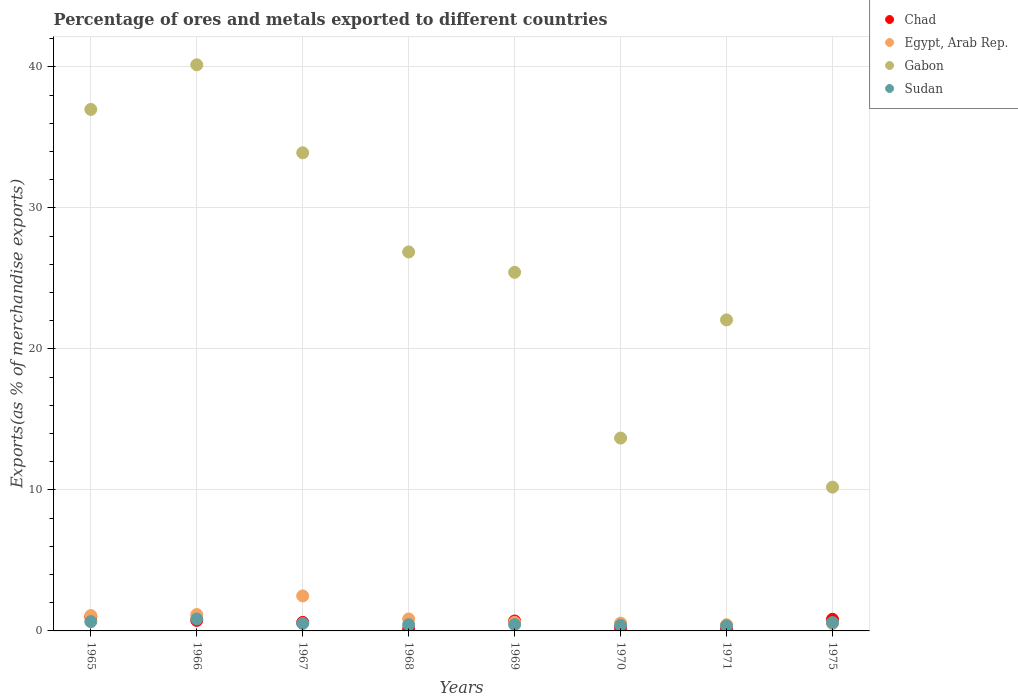Is the number of dotlines equal to the number of legend labels?
Your answer should be very brief. Yes. What is the percentage of exports to different countries in Egypt, Arab Rep. in 1967?
Provide a succinct answer. 2.48. Across all years, what is the maximum percentage of exports to different countries in Egypt, Arab Rep.?
Provide a succinct answer. 2.48. Across all years, what is the minimum percentage of exports to different countries in Sudan?
Offer a very short reply. 0.37. In which year was the percentage of exports to different countries in Chad maximum?
Ensure brevity in your answer.  1965. What is the total percentage of exports to different countries in Gabon in the graph?
Your response must be concise. 209.25. What is the difference between the percentage of exports to different countries in Chad in 1965 and that in 1966?
Offer a very short reply. 0.26. What is the difference between the percentage of exports to different countries in Egypt, Arab Rep. in 1967 and the percentage of exports to different countries in Chad in 1965?
Offer a very short reply. 1.48. What is the average percentage of exports to different countries in Sudan per year?
Offer a very short reply. 0.53. In the year 1967, what is the difference between the percentage of exports to different countries in Egypt, Arab Rep. and percentage of exports to different countries in Chad?
Your response must be concise. 1.88. What is the ratio of the percentage of exports to different countries in Sudan in 1966 to that in 1975?
Provide a succinct answer. 1.42. Is the difference between the percentage of exports to different countries in Egypt, Arab Rep. in 1965 and 1970 greater than the difference between the percentage of exports to different countries in Chad in 1965 and 1970?
Offer a very short reply. No. What is the difference between the highest and the second highest percentage of exports to different countries in Sudan?
Offer a very short reply. 0.19. What is the difference between the highest and the lowest percentage of exports to different countries in Chad?
Ensure brevity in your answer.  0.88. In how many years, is the percentage of exports to different countries in Egypt, Arab Rep. greater than the average percentage of exports to different countries in Egypt, Arab Rep. taken over all years?
Offer a terse response. 3. Is the sum of the percentage of exports to different countries in Gabon in 1969 and 1975 greater than the maximum percentage of exports to different countries in Egypt, Arab Rep. across all years?
Provide a short and direct response. Yes. Is it the case that in every year, the sum of the percentage of exports to different countries in Chad and percentage of exports to different countries in Gabon  is greater than the sum of percentage of exports to different countries in Egypt, Arab Rep. and percentage of exports to different countries in Sudan?
Offer a terse response. Yes. Is it the case that in every year, the sum of the percentage of exports to different countries in Chad and percentage of exports to different countries in Egypt, Arab Rep.  is greater than the percentage of exports to different countries in Sudan?
Your answer should be very brief. Yes. Does the percentage of exports to different countries in Gabon monotonically increase over the years?
Offer a very short reply. No. Is the percentage of exports to different countries in Egypt, Arab Rep. strictly greater than the percentage of exports to different countries in Sudan over the years?
Provide a succinct answer. No. How many years are there in the graph?
Provide a short and direct response. 8. What is the difference between two consecutive major ticks on the Y-axis?
Your answer should be very brief. 10. Are the values on the major ticks of Y-axis written in scientific E-notation?
Provide a short and direct response. No. Does the graph contain any zero values?
Your answer should be compact. No. Does the graph contain grids?
Keep it short and to the point. Yes. Where does the legend appear in the graph?
Your response must be concise. Top right. How many legend labels are there?
Your answer should be compact. 4. What is the title of the graph?
Keep it short and to the point. Percentage of ores and metals exported to different countries. Does "Belize" appear as one of the legend labels in the graph?
Keep it short and to the point. No. What is the label or title of the Y-axis?
Your answer should be compact. Exports(as % of merchandise exports). What is the Exports(as % of merchandise exports) in Chad in 1965?
Your answer should be very brief. 1.01. What is the Exports(as % of merchandise exports) in Egypt, Arab Rep. in 1965?
Keep it short and to the point. 1.09. What is the Exports(as % of merchandise exports) of Gabon in 1965?
Offer a very short reply. 36.98. What is the Exports(as % of merchandise exports) in Sudan in 1965?
Your answer should be compact. 0.66. What is the Exports(as % of merchandise exports) in Chad in 1966?
Ensure brevity in your answer.  0.75. What is the Exports(as % of merchandise exports) of Egypt, Arab Rep. in 1966?
Make the answer very short. 1.16. What is the Exports(as % of merchandise exports) of Gabon in 1966?
Provide a short and direct response. 40.14. What is the Exports(as % of merchandise exports) in Sudan in 1966?
Make the answer very short. 0.85. What is the Exports(as % of merchandise exports) of Chad in 1967?
Ensure brevity in your answer.  0.61. What is the Exports(as % of merchandise exports) of Egypt, Arab Rep. in 1967?
Your answer should be very brief. 2.48. What is the Exports(as % of merchandise exports) of Gabon in 1967?
Your answer should be compact. 33.9. What is the Exports(as % of merchandise exports) of Sudan in 1967?
Your response must be concise. 0.53. What is the Exports(as % of merchandise exports) in Chad in 1968?
Ensure brevity in your answer.  0.12. What is the Exports(as % of merchandise exports) in Egypt, Arab Rep. in 1968?
Make the answer very short. 0.85. What is the Exports(as % of merchandise exports) in Gabon in 1968?
Offer a terse response. 26.87. What is the Exports(as % of merchandise exports) of Sudan in 1968?
Make the answer very short. 0.44. What is the Exports(as % of merchandise exports) of Chad in 1969?
Provide a short and direct response. 0.7. What is the Exports(as % of merchandise exports) in Egypt, Arab Rep. in 1969?
Offer a terse response. 0.61. What is the Exports(as % of merchandise exports) of Gabon in 1969?
Provide a succinct answer. 25.43. What is the Exports(as % of merchandise exports) in Sudan in 1969?
Make the answer very short. 0.45. What is the Exports(as % of merchandise exports) of Chad in 1970?
Make the answer very short. 0.22. What is the Exports(as % of merchandise exports) of Egypt, Arab Rep. in 1970?
Provide a succinct answer. 0.55. What is the Exports(as % of merchandise exports) in Gabon in 1970?
Your answer should be compact. 13.68. What is the Exports(as % of merchandise exports) of Sudan in 1970?
Your answer should be very brief. 0.39. What is the Exports(as % of merchandise exports) of Chad in 1971?
Your answer should be very brief. 0.16. What is the Exports(as % of merchandise exports) in Egypt, Arab Rep. in 1971?
Your answer should be very brief. 0.44. What is the Exports(as % of merchandise exports) in Gabon in 1971?
Offer a very short reply. 22.05. What is the Exports(as % of merchandise exports) in Sudan in 1971?
Make the answer very short. 0.37. What is the Exports(as % of merchandise exports) of Chad in 1975?
Offer a terse response. 0.82. What is the Exports(as % of merchandise exports) in Egypt, Arab Rep. in 1975?
Provide a succinct answer. 0.52. What is the Exports(as % of merchandise exports) in Gabon in 1975?
Provide a short and direct response. 10.19. What is the Exports(as % of merchandise exports) in Sudan in 1975?
Your response must be concise. 0.59. Across all years, what is the maximum Exports(as % of merchandise exports) in Chad?
Make the answer very short. 1.01. Across all years, what is the maximum Exports(as % of merchandise exports) of Egypt, Arab Rep.?
Your response must be concise. 2.48. Across all years, what is the maximum Exports(as % of merchandise exports) in Gabon?
Your answer should be very brief. 40.14. Across all years, what is the maximum Exports(as % of merchandise exports) of Sudan?
Your answer should be very brief. 0.85. Across all years, what is the minimum Exports(as % of merchandise exports) in Chad?
Your answer should be very brief. 0.12. Across all years, what is the minimum Exports(as % of merchandise exports) in Egypt, Arab Rep.?
Make the answer very short. 0.44. Across all years, what is the minimum Exports(as % of merchandise exports) in Gabon?
Ensure brevity in your answer.  10.19. Across all years, what is the minimum Exports(as % of merchandise exports) in Sudan?
Provide a succinct answer. 0.37. What is the total Exports(as % of merchandise exports) of Chad in the graph?
Offer a very short reply. 4.38. What is the total Exports(as % of merchandise exports) of Egypt, Arab Rep. in the graph?
Provide a succinct answer. 7.7. What is the total Exports(as % of merchandise exports) in Gabon in the graph?
Keep it short and to the point. 209.25. What is the total Exports(as % of merchandise exports) in Sudan in the graph?
Give a very brief answer. 4.27. What is the difference between the Exports(as % of merchandise exports) in Chad in 1965 and that in 1966?
Keep it short and to the point. 0.26. What is the difference between the Exports(as % of merchandise exports) of Egypt, Arab Rep. in 1965 and that in 1966?
Make the answer very short. -0.07. What is the difference between the Exports(as % of merchandise exports) of Gabon in 1965 and that in 1966?
Provide a short and direct response. -3.17. What is the difference between the Exports(as % of merchandise exports) of Sudan in 1965 and that in 1966?
Offer a terse response. -0.19. What is the difference between the Exports(as % of merchandise exports) in Chad in 1965 and that in 1967?
Provide a succinct answer. 0.4. What is the difference between the Exports(as % of merchandise exports) of Egypt, Arab Rep. in 1965 and that in 1967?
Offer a very short reply. -1.39. What is the difference between the Exports(as % of merchandise exports) in Gabon in 1965 and that in 1967?
Your answer should be very brief. 3.07. What is the difference between the Exports(as % of merchandise exports) of Sudan in 1965 and that in 1967?
Ensure brevity in your answer.  0.13. What is the difference between the Exports(as % of merchandise exports) in Chad in 1965 and that in 1968?
Offer a very short reply. 0.88. What is the difference between the Exports(as % of merchandise exports) in Egypt, Arab Rep. in 1965 and that in 1968?
Your answer should be compact. 0.24. What is the difference between the Exports(as % of merchandise exports) in Gabon in 1965 and that in 1968?
Your answer should be very brief. 10.1. What is the difference between the Exports(as % of merchandise exports) in Sudan in 1965 and that in 1968?
Keep it short and to the point. 0.22. What is the difference between the Exports(as % of merchandise exports) in Chad in 1965 and that in 1969?
Keep it short and to the point. 0.3. What is the difference between the Exports(as % of merchandise exports) in Egypt, Arab Rep. in 1965 and that in 1969?
Offer a terse response. 0.48. What is the difference between the Exports(as % of merchandise exports) of Gabon in 1965 and that in 1969?
Your answer should be very brief. 11.55. What is the difference between the Exports(as % of merchandise exports) of Sudan in 1965 and that in 1969?
Provide a short and direct response. 0.21. What is the difference between the Exports(as % of merchandise exports) in Chad in 1965 and that in 1970?
Ensure brevity in your answer.  0.79. What is the difference between the Exports(as % of merchandise exports) of Egypt, Arab Rep. in 1965 and that in 1970?
Provide a succinct answer. 0.53. What is the difference between the Exports(as % of merchandise exports) in Gabon in 1965 and that in 1970?
Offer a terse response. 23.3. What is the difference between the Exports(as % of merchandise exports) in Sudan in 1965 and that in 1970?
Give a very brief answer. 0.27. What is the difference between the Exports(as % of merchandise exports) in Chad in 1965 and that in 1971?
Your response must be concise. 0.85. What is the difference between the Exports(as % of merchandise exports) of Egypt, Arab Rep. in 1965 and that in 1971?
Make the answer very short. 0.65. What is the difference between the Exports(as % of merchandise exports) in Gabon in 1965 and that in 1971?
Your response must be concise. 14.92. What is the difference between the Exports(as % of merchandise exports) of Sudan in 1965 and that in 1971?
Keep it short and to the point. 0.29. What is the difference between the Exports(as % of merchandise exports) of Chad in 1965 and that in 1975?
Offer a terse response. 0.18. What is the difference between the Exports(as % of merchandise exports) in Egypt, Arab Rep. in 1965 and that in 1975?
Your answer should be compact. 0.56. What is the difference between the Exports(as % of merchandise exports) of Gabon in 1965 and that in 1975?
Your response must be concise. 26.78. What is the difference between the Exports(as % of merchandise exports) of Sudan in 1965 and that in 1975?
Provide a succinct answer. 0.07. What is the difference between the Exports(as % of merchandise exports) of Chad in 1966 and that in 1967?
Provide a short and direct response. 0.14. What is the difference between the Exports(as % of merchandise exports) of Egypt, Arab Rep. in 1966 and that in 1967?
Keep it short and to the point. -1.32. What is the difference between the Exports(as % of merchandise exports) of Gabon in 1966 and that in 1967?
Offer a terse response. 6.24. What is the difference between the Exports(as % of merchandise exports) of Sudan in 1966 and that in 1967?
Provide a short and direct response. 0.32. What is the difference between the Exports(as % of merchandise exports) in Chad in 1966 and that in 1968?
Offer a very short reply. 0.62. What is the difference between the Exports(as % of merchandise exports) in Egypt, Arab Rep. in 1966 and that in 1968?
Provide a short and direct response. 0.31. What is the difference between the Exports(as % of merchandise exports) of Gabon in 1966 and that in 1968?
Keep it short and to the point. 13.27. What is the difference between the Exports(as % of merchandise exports) of Sudan in 1966 and that in 1968?
Your answer should be compact. 0.41. What is the difference between the Exports(as % of merchandise exports) of Chad in 1966 and that in 1969?
Offer a very short reply. 0.04. What is the difference between the Exports(as % of merchandise exports) of Egypt, Arab Rep. in 1966 and that in 1969?
Your answer should be compact. 0.55. What is the difference between the Exports(as % of merchandise exports) of Gabon in 1966 and that in 1969?
Ensure brevity in your answer.  14.71. What is the difference between the Exports(as % of merchandise exports) of Chad in 1966 and that in 1970?
Offer a terse response. 0.53. What is the difference between the Exports(as % of merchandise exports) of Egypt, Arab Rep. in 1966 and that in 1970?
Provide a short and direct response. 0.61. What is the difference between the Exports(as % of merchandise exports) in Gabon in 1966 and that in 1970?
Ensure brevity in your answer.  26.47. What is the difference between the Exports(as % of merchandise exports) in Sudan in 1966 and that in 1970?
Offer a very short reply. 0.45. What is the difference between the Exports(as % of merchandise exports) of Chad in 1966 and that in 1971?
Keep it short and to the point. 0.59. What is the difference between the Exports(as % of merchandise exports) of Egypt, Arab Rep. in 1966 and that in 1971?
Your answer should be very brief. 0.72. What is the difference between the Exports(as % of merchandise exports) of Gabon in 1966 and that in 1971?
Provide a short and direct response. 18.09. What is the difference between the Exports(as % of merchandise exports) in Sudan in 1966 and that in 1971?
Offer a very short reply. 0.48. What is the difference between the Exports(as % of merchandise exports) of Chad in 1966 and that in 1975?
Your response must be concise. -0.08. What is the difference between the Exports(as % of merchandise exports) of Egypt, Arab Rep. in 1966 and that in 1975?
Offer a very short reply. 0.64. What is the difference between the Exports(as % of merchandise exports) of Gabon in 1966 and that in 1975?
Provide a short and direct response. 29.95. What is the difference between the Exports(as % of merchandise exports) of Sudan in 1966 and that in 1975?
Offer a terse response. 0.25. What is the difference between the Exports(as % of merchandise exports) of Chad in 1967 and that in 1968?
Keep it short and to the point. 0.48. What is the difference between the Exports(as % of merchandise exports) in Egypt, Arab Rep. in 1967 and that in 1968?
Your answer should be very brief. 1.63. What is the difference between the Exports(as % of merchandise exports) of Gabon in 1967 and that in 1968?
Your response must be concise. 7.03. What is the difference between the Exports(as % of merchandise exports) of Sudan in 1967 and that in 1968?
Keep it short and to the point. 0.09. What is the difference between the Exports(as % of merchandise exports) in Chad in 1967 and that in 1969?
Keep it short and to the point. -0.1. What is the difference between the Exports(as % of merchandise exports) of Egypt, Arab Rep. in 1967 and that in 1969?
Your answer should be compact. 1.88. What is the difference between the Exports(as % of merchandise exports) in Gabon in 1967 and that in 1969?
Give a very brief answer. 8.48. What is the difference between the Exports(as % of merchandise exports) of Sudan in 1967 and that in 1969?
Your answer should be compact. 0.08. What is the difference between the Exports(as % of merchandise exports) in Chad in 1967 and that in 1970?
Provide a short and direct response. 0.39. What is the difference between the Exports(as % of merchandise exports) of Egypt, Arab Rep. in 1967 and that in 1970?
Ensure brevity in your answer.  1.93. What is the difference between the Exports(as % of merchandise exports) of Gabon in 1967 and that in 1970?
Your answer should be very brief. 20.23. What is the difference between the Exports(as % of merchandise exports) in Sudan in 1967 and that in 1970?
Give a very brief answer. 0.14. What is the difference between the Exports(as % of merchandise exports) in Chad in 1967 and that in 1971?
Give a very brief answer. 0.45. What is the difference between the Exports(as % of merchandise exports) of Egypt, Arab Rep. in 1967 and that in 1971?
Ensure brevity in your answer.  2.04. What is the difference between the Exports(as % of merchandise exports) of Gabon in 1967 and that in 1971?
Your answer should be very brief. 11.85. What is the difference between the Exports(as % of merchandise exports) in Sudan in 1967 and that in 1971?
Provide a short and direct response. 0.17. What is the difference between the Exports(as % of merchandise exports) in Chad in 1967 and that in 1975?
Offer a terse response. -0.22. What is the difference between the Exports(as % of merchandise exports) of Egypt, Arab Rep. in 1967 and that in 1975?
Your response must be concise. 1.96. What is the difference between the Exports(as % of merchandise exports) of Gabon in 1967 and that in 1975?
Your answer should be compact. 23.71. What is the difference between the Exports(as % of merchandise exports) in Sudan in 1967 and that in 1975?
Your response must be concise. -0.06. What is the difference between the Exports(as % of merchandise exports) of Chad in 1968 and that in 1969?
Provide a succinct answer. -0.58. What is the difference between the Exports(as % of merchandise exports) in Egypt, Arab Rep. in 1968 and that in 1969?
Provide a short and direct response. 0.24. What is the difference between the Exports(as % of merchandise exports) of Gabon in 1968 and that in 1969?
Your answer should be very brief. 1.44. What is the difference between the Exports(as % of merchandise exports) in Sudan in 1968 and that in 1969?
Make the answer very short. -0.01. What is the difference between the Exports(as % of merchandise exports) in Chad in 1968 and that in 1970?
Provide a succinct answer. -0.1. What is the difference between the Exports(as % of merchandise exports) of Egypt, Arab Rep. in 1968 and that in 1970?
Keep it short and to the point. 0.29. What is the difference between the Exports(as % of merchandise exports) of Gabon in 1968 and that in 1970?
Provide a short and direct response. 13.2. What is the difference between the Exports(as % of merchandise exports) in Sudan in 1968 and that in 1970?
Your answer should be very brief. 0.05. What is the difference between the Exports(as % of merchandise exports) in Chad in 1968 and that in 1971?
Give a very brief answer. -0.04. What is the difference between the Exports(as % of merchandise exports) in Egypt, Arab Rep. in 1968 and that in 1971?
Provide a short and direct response. 0.41. What is the difference between the Exports(as % of merchandise exports) of Gabon in 1968 and that in 1971?
Provide a short and direct response. 4.82. What is the difference between the Exports(as % of merchandise exports) in Sudan in 1968 and that in 1971?
Provide a succinct answer. 0.07. What is the difference between the Exports(as % of merchandise exports) of Chad in 1968 and that in 1975?
Provide a succinct answer. -0.7. What is the difference between the Exports(as % of merchandise exports) of Egypt, Arab Rep. in 1968 and that in 1975?
Offer a terse response. 0.32. What is the difference between the Exports(as % of merchandise exports) of Gabon in 1968 and that in 1975?
Give a very brief answer. 16.68. What is the difference between the Exports(as % of merchandise exports) in Sudan in 1968 and that in 1975?
Provide a short and direct response. -0.15. What is the difference between the Exports(as % of merchandise exports) in Chad in 1969 and that in 1970?
Your answer should be compact. 0.48. What is the difference between the Exports(as % of merchandise exports) in Egypt, Arab Rep. in 1969 and that in 1970?
Your answer should be compact. 0.05. What is the difference between the Exports(as % of merchandise exports) of Gabon in 1969 and that in 1970?
Make the answer very short. 11.75. What is the difference between the Exports(as % of merchandise exports) in Sudan in 1969 and that in 1970?
Your answer should be compact. 0.05. What is the difference between the Exports(as % of merchandise exports) in Chad in 1969 and that in 1971?
Your answer should be very brief. 0.54. What is the difference between the Exports(as % of merchandise exports) in Egypt, Arab Rep. in 1969 and that in 1971?
Make the answer very short. 0.17. What is the difference between the Exports(as % of merchandise exports) of Gabon in 1969 and that in 1971?
Provide a succinct answer. 3.37. What is the difference between the Exports(as % of merchandise exports) of Sudan in 1969 and that in 1971?
Provide a short and direct response. 0.08. What is the difference between the Exports(as % of merchandise exports) in Chad in 1969 and that in 1975?
Make the answer very short. -0.12. What is the difference between the Exports(as % of merchandise exports) of Egypt, Arab Rep. in 1969 and that in 1975?
Offer a terse response. 0.08. What is the difference between the Exports(as % of merchandise exports) of Gabon in 1969 and that in 1975?
Offer a terse response. 15.23. What is the difference between the Exports(as % of merchandise exports) in Sudan in 1969 and that in 1975?
Give a very brief answer. -0.15. What is the difference between the Exports(as % of merchandise exports) of Chad in 1970 and that in 1971?
Provide a succinct answer. 0.06. What is the difference between the Exports(as % of merchandise exports) in Egypt, Arab Rep. in 1970 and that in 1971?
Keep it short and to the point. 0.12. What is the difference between the Exports(as % of merchandise exports) in Gabon in 1970 and that in 1971?
Your answer should be very brief. -8.38. What is the difference between the Exports(as % of merchandise exports) of Sudan in 1970 and that in 1971?
Your answer should be very brief. 0.03. What is the difference between the Exports(as % of merchandise exports) of Chad in 1970 and that in 1975?
Provide a short and direct response. -0.6. What is the difference between the Exports(as % of merchandise exports) of Egypt, Arab Rep. in 1970 and that in 1975?
Your answer should be compact. 0.03. What is the difference between the Exports(as % of merchandise exports) of Gabon in 1970 and that in 1975?
Give a very brief answer. 3.48. What is the difference between the Exports(as % of merchandise exports) of Sudan in 1970 and that in 1975?
Offer a terse response. -0.2. What is the difference between the Exports(as % of merchandise exports) of Chad in 1971 and that in 1975?
Offer a terse response. -0.66. What is the difference between the Exports(as % of merchandise exports) of Egypt, Arab Rep. in 1971 and that in 1975?
Your answer should be compact. -0.09. What is the difference between the Exports(as % of merchandise exports) in Gabon in 1971 and that in 1975?
Make the answer very short. 11.86. What is the difference between the Exports(as % of merchandise exports) in Sudan in 1971 and that in 1975?
Your response must be concise. -0.23. What is the difference between the Exports(as % of merchandise exports) in Chad in 1965 and the Exports(as % of merchandise exports) in Egypt, Arab Rep. in 1966?
Your answer should be compact. -0.15. What is the difference between the Exports(as % of merchandise exports) of Chad in 1965 and the Exports(as % of merchandise exports) of Gabon in 1966?
Provide a short and direct response. -39.14. What is the difference between the Exports(as % of merchandise exports) of Chad in 1965 and the Exports(as % of merchandise exports) of Sudan in 1966?
Keep it short and to the point. 0.16. What is the difference between the Exports(as % of merchandise exports) in Egypt, Arab Rep. in 1965 and the Exports(as % of merchandise exports) in Gabon in 1966?
Keep it short and to the point. -39.05. What is the difference between the Exports(as % of merchandise exports) in Egypt, Arab Rep. in 1965 and the Exports(as % of merchandise exports) in Sudan in 1966?
Offer a terse response. 0.24. What is the difference between the Exports(as % of merchandise exports) of Gabon in 1965 and the Exports(as % of merchandise exports) of Sudan in 1966?
Provide a succinct answer. 36.13. What is the difference between the Exports(as % of merchandise exports) of Chad in 1965 and the Exports(as % of merchandise exports) of Egypt, Arab Rep. in 1967?
Provide a short and direct response. -1.48. What is the difference between the Exports(as % of merchandise exports) in Chad in 1965 and the Exports(as % of merchandise exports) in Gabon in 1967?
Keep it short and to the point. -32.9. What is the difference between the Exports(as % of merchandise exports) of Chad in 1965 and the Exports(as % of merchandise exports) of Sudan in 1967?
Provide a succinct answer. 0.48. What is the difference between the Exports(as % of merchandise exports) in Egypt, Arab Rep. in 1965 and the Exports(as % of merchandise exports) in Gabon in 1967?
Your answer should be compact. -32.82. What is the difference between the Exports(as % of merchandise exports) in Egypt, Arab Rep. in 1965 and the Exports(as % of merchandise exports) in Sudan in 1967?
Offer a terse response. 0.56. What is the difference between the Exports(as % of merchandise exports) of Gabon in 1965 and the Exports(as % of merchandise exports) of Sudan in 1967?
Provide a succinct answer. 36.45. What is the difference between the Exports(as % of merchandise exports) of Chad in 1965 and the Exports(as % of merchandise exports) of Egypt, Arab Rep. in 1968?
Your response must be concise. 0.16. What is the difference between the Exports(as % of merchandise exports) of Chad in 1965 and the Exports(as % of merchandise exports) of Gabon in 1968?
Ensure brevity in your answer.  -25.87. What is the difference between the Exports(as % of merchandise exports) of Chad in 1965 and the Exports(as % of merchandise exports) of Sudan in 1968?
Your response must be concise. 0.57. What is the difference between the Exports(as % of merchandise exports) of Egypt, Arab Rep. in 1965 and the Exports(as % of merchandise exports) of Gabon in 1968?
Give a very brief answer. -25.78. What is the difference between the Exports(as % of merchandise exports) of Egypt, Arab Rep. in 1965 and the Exports(as % of merchandise exports) of Sudan in 1968?
Give a very brief answer. 0.65. What is the difference between the Exports(as % of merchandise exports) in Gabon in 1965 and the Exports(as % of merchandise exports) in Sudan in 1968?
Offer a terse response. 36.54. What is the difference between the Exports(as % of merchandise exports) of Chad in 1965 and the Exports(as % of merchandise exports) of Egypt, Arab Rep. in 1969?
Your response must be concise. 0.4. What is the difference between the Exports(as % of merchandise exports) in Chad in 1965 and the Exports(as % of merchandise exports) in Gabon in 1969?
Ensure brevity in your answer.  -24.42. What is the difference between the Exports(as % of merchandise exports) of Chad in 1965 and the Exports(as % of merchandise exports) of Sudan in 1969?
Your response must be concise. 0.56. What is the difference between the Exports(as % of merchandise exports) in Egypt, Arab Rep. in 1965 and the Exports(as % of merchandise exports) in Gabon in 1969?
Give a very brief answer. -24.34. What is the difference between the Exports(as % of merchandise exports) in Egypt, Arab Rep. in 1965 and the Exports(as % of merchandise exports) in Sudan in 1969?
Your answer should be compact. 0.64. What is the difference between the Exports(as % of merchandise exports) of Gabon in 1965 and the Exports(as % of merchandise exports) of Sudan in 1969?
Make the answer very short. 36.53. What is the difference between the Exports(as % of merchandise exports) in Chad in 1965 and the Exports(as % of merchandise exports) in Egypt, Arab Rep. in 1970?
Your answer should be compact. 0.45. What is the difference between the Exports(as % of merchandise exports) in Chad in 1965 and the Exports(as % of merchandise exports) in Gabon in 1970?
Make the answer very short. -12.67. What is the difference between the Exports(as % of merchandise exports) of Chad in 1965 and the Exports(as % of merchandise exports) of Sudan in 1970?
Ensure brevity in your answer.  0.61. What is the difference between the Exports(as % of merchandise exports) in Egypt, Arab Rep. in 1965 and the Exports(as % of merchandise exports) in Gabon in 1970?
Offer a terse response. -12.59. What is the difference between the Exports(as % of merchandise exports) in Egypt, Arab Rep. in 1965 and the Exports(as % of merchandise exports) in Sudan in 1970?
Ensure brevity in your answer.  0.7. What is the difference between the Exports(as % of merchandise exports) of Gabon in 1965 and the Exports(as % of merchandise exports) of Sudan in 1970?
Keep it short and to the point. 36.58. What is the difference between the Exports(as % of merchandise exports) in Chad in 1965 and the Exports(as % of merchandise exports) in Egypt, Arab Rep. in 1971?
Offer a very short reply. 0.57. What is the difference between the Exports(as % of merchandise exports) of Chad in 1965 and the Exports(as % of merchandise exports) of Gabon in 1971?
Ensure brevity in your answer.  -21.05. What is the difference between the Exports(as % of merchandise exports) of Chad in 1965 and the Exports(as % of merchandise exports) of Sudan in 1971?
Provide a succinct answer. 0.64. What is the difference between the Exports(as % of merchandise exports) in Egypt, Arab Rep. in 1965 and the Exports(as % of merchandise exports) in Gabon in 1971?
Your answer should be compact. -20.97. What is the difference between the Exports(as % of merchandise exports) in Egypt, Arab Rep. in 1965 and the Exports(as % of merchandise exports) in Sudan in 1971?
Keep it short and to the point. 0.72. What is the difference between the Exports(as % of merchandise exports) in Gabon in 1965 and the Exports(as % of merchandise exports) in Sudan in 1971?
Ensure brevity in your answer.  36.61. What is the difference between the Exports(as % of merchandise exports) in Chad in 1965 and the Exports(as % of merchandise exports) in Egypt, Arab Rep. in 1975?
Keep it short and to the point. 0.48. What is the difference between the Exports(as % of merchandise exports) of Chad in 1965 and the Exports(as % of merchandise exports) of Gabon in 1975?
Make the answer very short. -9.19. What is the difference between the Exports(as % of merchandise exports) of Chad in 1965 and the Exports(as % of merchandise exports) of Sudan in 1975?
Your response must be concise. 0.41. What is the difference between the Exports(as % of merchandise exports) in Egypt, Arab Rep. in 1965 and the Exports(as % of merchandise exports) in Gabon in 1975?
Your response must be concise. -9.11. What is the difference between the Exports(as % of merchandise exports) of Egypt, Arab Rep. in 1965 and the Exports(as % of merchandise exports) of Sudan in 1975?
Provide a short and direct response. 0.49. What is the difference between the Exports(as % of merchandise exports) of Gabon in 1965 and the Exports(as % of merchandise exports) of Sudan in 1975?
Your response must be concise. 36.38. What is the difference between the Exports(as % of merchandise exports) of Chad in 1966 and the Exports(as % of merchandise exports) of Egypt, Arab Rep. in 1967?
Ensure brevity in your answer.  -1.74. What is the difference between the Exports(as % of merchandise exports) of Chad in 1966 and the Exports(as % of merchandise exports) of Gabon in 1967?
Give a very brief answer. -33.16. What is the difference between the Exports(as % of merchandise exports) of Chad in 1966 and the Exports(as % of merchandise exports) of Sudan in 1967?
Offer a terse response. 0.22. What is the difference between the Exports(as % of merchandise exports) of Egypt, Arab Rep. in 1966 and the Exports(as % of merchandise exports) of Gabon in 1967?
Your answer should be compact. -32.74. What is the difference between the Exports(as % of merchandise exports) of Egypt, Arab Rep. in 1966 and the Exports(as % of merchandise exports) of Sudan in 1967?
Ensure brevity in your answer.  0.63. What is the difference between the Exports(as % of merchandise exports) in Gabon in 1966 and the Exports(as % of merchandise exports) in Sudan in 1967?
Offer a terse response. 39.61. What is the difference between the Exports(as % of merchandise exports) in Chad in 1966 and the Exports(as % of merchandise exports) in Egypt, Arab Rep. in 1968?
Your answer should be compact. -0.1. What is the difference between the Exports(as % of merchandise exports) in Chad in 1966 and the Exports(as % of merchandise exports) in Gabon in 1968?
Provide a short and direct response. -26.13. What is the difference between the Exports(as % of merchandise exports) of Chad in 1966 and the Exports(as % of merchandise exports) of Sudan in 1968?
Your answer should be compact. 0.31. What is the difference between the Exports(as % of merchandise exports) in Egypt, Arab Rep. in 1966 and the Exports(as % of merchandise exports) in Gabon in 1968?
Your answer should be very brief. -25.71. What is the difference between the Exports(as % of merchandise exports) in Egypt, Arab Rep. in 1966 and the Exports(as % of merchandise exports) in Sudan in 1968?
Your response must be concise. 0.72. What is the difference between the Exports(as % of merchandise exports) of Gabon in 1966 and the Exports(as % of merchandise exports) of Sudan in 1968?
Your answer should be compact. 39.7. What is the difference between the Exports(as % of merchandise exports) in Chad in 1966 and the Exports(as % of merchandise exports) in Egypt, Arab Rep. in 1969?
Ensure brevity in your answer.  0.14. What is the difference between the Exports(as % of merchandise exports) of Chad in 1966 and the Exports(as % of merchandise exports) of Gabon in 1969?
Ensure brevity in your answer.  -24.68. What is the difference between the Exports(as % of merchandise exports) of Chad in 1966 and the Exports(as % of merchandise exports) of Sudan in 1969?
Your answer should be compact. 0.3. What is the difference between the Exports(as % of merchandise exports) in Egypt, Arab Rep. in 1966 and the Exports(as % of merchandise exports) in Gabon in 1969?
Provide a succinct answer. -24.27. What is the difference between the Exports(as % of merchandise exports) of Egypt, Arab Rep. in 1966 and the Exports(as % of merchandise exports) of Sudan in 1969?
Ensure brevity in your answer.  0.71. What is the difference between the Exports(as % of merchandise exports) in Gabon in 1966 and the Exports(as % of merchandise exports) in Sudan in 1969?
Keep it short and to the point. 39.7. What is the difference between the Exports(as % of merchandise exports) in Chad in 1966 and the Exports(as % of merchandise exports) in Egypt, Arab Rep. in 1970?
Provide a succinct answer. 0.19. What is the difference between the Exports(as % of merchandise exports) of Chad in 1966 and the Exports(as % of merchandise exports) of Gabon in 1970?
Give a very brief answer. -12.93. What is the difference between the Exports(as % of merchandise exports) in Chad in 1966 and the Exports(as % of merchandise exports) in Sudan in 1970?
Your answer should be compact. 0.35. What is the difference between the Exports(as % of merchandise exports) of Egypt, Arab Rep. in 1966 and the Exports(as % of merchandise exports) of Gabon in 1970?
Offer a very short reply. -12.52. What is the difference between the Exports(as % of merchandise exports) in Egypt, Arab Rep. in 1966 and the Exports(as % of merchandise exports) in Sudan in 1970?
Ensure brevity in your answer.  0.77. What is the difference between the Exports(as % of merchandise exports) of Gabon in 1966 and the Exports(as % of merchandise exports) of Sudan in 1970?
Your response must be concise. 39.75. What is the difference between the Exports(as % of merchandise exports) in Chad in 1966 and the Exports(as % of merchandise exports) in Egypt, Arab Rep. in 1971?
Your answer should be very brief. 0.31. What is the difference between the Exports(as % of merchandise exports) of Chad in 1966 and the Exports(as % of merchandise exports) of Gabon in 1971?
Offer a terse response. -21.31. What is the difference between the Exports(as % of merchandise exports) of Chad in 1966 and the Exports(as % of merchandise exports) of Sudan in 1971?
Make the answer very short. 0.38. What is the difference between the Exports(as % of merchandise exports) of Egypt, Arab Rep. in 1966 and the Exports(as % of merchandise exports) of Gabon in 1971?
Make the answer very short. -20.89. What is the difference between the Exports(as % of merchandise exports) in Egypt, Arab Rep. in 1966 and the Exports(as % of merchandise exports) in Sudan in 1971?
Your answer should be very brief. 0.8. What is the difference between the Exports(as % of merchandise exports) in Gabon in 1966 and the Exports(as % of merchandise exports) in Sudan in 1971?
Offer a terse response. 39.78. What is the difference between the Exports(as % of merchandise exports) in Chad in 1966 and the Exports(as % of merchandise exports) in Egypt, Arab Rep. in 1975?
Offer a very short reply. 0.22. What is the difference between the Exports(as % of merchandise exports) of Chad in 1966 and the Exports(as % of merchandise exports) of Gabon in 1975?
Keep it short and to the point. -9.45. What is the difference between the Exports(as % of merchandise exports) of Chad in 1966 and the Exports(as % of merchandise exports) of Sudan in 1975?
Provide a succinct answer. 0.15. What is the difference between the Exports(as % of merchandise exports) in Egypt, Arab Rep. in 1966 and the Exports(as % of merchandise exports) in Gabon in 1975?
Provide a succinct answer. -9.03. What is the difference between the Exports(as % of merchandise exports) of Egypt, Arab Rep. in 1966 and the Exports(as % of merchandise exports) of Sudan in 1975?
Make the answer very short. 0.57. What is the difference between the Exports(as % of merchandise exports) in Gabon in 1966 and the Exports(as % of merchandise exports) in Sudan in 1975?
Make the answer very short. 39.55. What is the difference between the Exports(as % of merchandise exports) of Chad in 1967 and the Exports(as % of merchandise exports) of Egypt, Arab Rep. in 1968?
Give a very brief answer. -0.24. What is the difference between the Exports(as % of merchandise exports) of Chad in 1967 and the Exports(as % of merchandise exports) of Gabon in 1968?
Make the answer very short. -26.27. What is the difference between the Exports(as % of merchandise exports) of Chad in 1967 and the Exports(as % of merchandise exports) of Sudan in 1968?
Provide a short and direct response. 0.17. What is the difference between the Exports(as % of merchandise exports) in Egypt, Arab Rep. in 1967 and the Exports(as % of merchandise exports) in Gabon in 1968?
Provide a short and direct response. -24.39. What is the difference between the Exports(as % of merchandise exports) of Egypt, Arab Rep. in 1967 and the Exports(as % of merchandise exports) of Sudan in 1968?
Your response must be concise. 2.04. What is the difference between the Exports(as % of merchandise exports) of Gabon in 1967 and the Exports(as % of merchandise exports) of Sudan in 1968?
Provide a short and direct response. 33.46. What is the difference between the Exports(as % of merchandise exports) in Chad in 1967 and the Exports(as % of merchandise exports) in Egypt, Arab Rep. in 1969?
Offer a terse response. 0. What is the difference between the Exports(as % of merchandise exports) in Chad in 1967 and the Exports(as % of merchandise exports) in Gabon in 1969?
Your answer should be very brief. -24.82. What is the difference between the Exports(as % of merchandise exports) in Chad in 1967 and the Exports(as % of merchandise exports) in Sudan in 1969?
Offer a very short reply. 0.16. What is the difference between the Exports(as % of merchandise exports) of Egypt, Arab Rep. in 1967 and the Exports(as % of merchandise exports) of Gabon in 1969?
Provide a succinct answer. -22.95. What is the difference between the Exports(as % of merchandise exports) in Egypt, Arab Rep. in 1967 and the Exports(as % of merchandise exports) in Sudan in 1969?
Provide a succinct answer. 2.04. What is the difference between the Exports(as % of merchandise exports) of Gabon in 1967 and the Exports(as % of merchandise exports) of Sudan in 1969?
Provide a succinct answer. 33.46. What is the difference between the Exports(as % of merchandise exports) in Chad in 1967 and the Exports(as % of merchandise exports) in Egypt, Arab Rep. in 1970?
Provide a succinct answer. 0.05. What is the difference between the Exports(as % of merchandise exports) in Chad in 1967 and the Exports(as % of merchandise exports) in Gabon in 1970?
Your answer should be compact. -13.07. What is the difference between the Exports(as % of merchandise exports) in Chad in 1967 and the Exports(as % of merchandise exports) in Sudan in 1970?
Provide a succinct answer. 0.21. What is the difference between the Exports(as % of merchandise exports) of Egypt, Arab Rep. in 1967 and the Exports(as % of merchandise exports) of Gabon in 1970?
Your response must be concise. -11.19. What is the difference between the Exports(as % of merchandise exports) of Egypt, Arab Rep. in 1967 and the Exports(as % of merchandise exports) of Sudan in 1970?
Provide a succinct answer. 2.09. What is the difference between the Exports(as % of merchandise exports) of Gabon in 1967 and the Exports(as % of merchandise exports) of Sudan in 1970?
Offer a very short reply. 33.51. What is the difference between the Exports(as % of merchandise exports) of Chad in 1967 and the Exports(as % of merchandise exports) of Egypt, Arab Rep. in 1971?
Your response must be concise. 0.17. What is the difference between the Exports(as % of merchandise exports) in Chad in 1967 and the Exports(as % of merchandise exports) in Gabon in 1971?
Your answer should be very brief. -21.45. What is the difference between the Exports(as % of merchandise exports) in Chad in 1967 and the Exports(as % of merchandise exports) in Sudan in 1971?
Offer a very short reply. 0.24. What is the difference between the Exports(as % of merchandise exports) of Egypt, Arab Rep. in 1967 and the Exports(as % of merchandise exports) of Gabon in 1971?
Keep it short and to the point. -19.57. What is the difference between the Exports(as % of merchandise exports) of Egypt, Arab Rep. in 1967 and the Exports(as % of merchandise exports) of Sudan in 1971?
Give a very brief answer. 2.12. What is the difference between the Exports(as % of merchandise exports) of Gabon in 1967 and the Exports(as % of merchandise exports) of Sudan in 1971?
Provide a succinct answer. 33.54. What is the difference between the Exports(as % of merchandise exports) in Chad in 1967 and the Exports(as % of merchandise exports) in Egypt, Arab Rep. in 1975?
Make the answer very short. 0.08. What is the difference between the Exports(as % of merchandise exports) in Chad in 1967 and the Exports(as % of merchandise exports) in Gabon in 1975?
Make the answer very short. -9.59. What is the difference between the Exports(as % of merchandise exports) of Chad in 1967 and the Exports(as % of merchandise exports) of Sudan in 1975?
Your answer should be very brief. 0.01. What is the difference between the Exports(as % of merchandise exports) in Egypt, Arab Rep. in 1967 and the Exports(as % of merchandise exports) in Gabon in 1975?
Offer a very short reply. -7.71. What is the difference between the Exports(as % of merchandise exports) in Egypt, Arab Rep. in 1967 and the Exports(as % of merchandise exports) in Sudan in 1975?
Give a very brief answer. 1.89. What is the difference between the Exports(as % of merchandise exports) in Gabon in 1967 and the Exports(as % of merchandise exports) in Sudan in 1975?
Your response must be concise. 33.31. What is the difference between the Exports(as % of merchandise exports) in Chad in 1968 and the Exports(as % of merchandise exports) in Egypt, Arab Rep. in 1969?
Ensure brevity in your answer.  -0.48. What is the difference between the Exports(as % of merchandise exports) in Chad in 1968 and the Exports(as % of merchandise exports) in Gabon in 1969?
Offer a very short reply. -25.31. What is the difference between the Exports(as % of merchandise exports) of Chad in 1968 and the Exports(as % of merchandise exports) of Sudan in 1969?
Your response must be concise. -0.32. What is the difference between the Exports(as % of merchandise exports) of Egypt, Arab Rep. in 1968 and the Exports(as % of merchandise exports) of Gabon in 1969?
Keep it short and to the point. -24.58. What is the difference between the Exports(as % of merchandise exports) of Egypt, Arab Rep. in 1968 and the Exports(as % of merchandise exports) of Sudan in 1969?
Your response must be concise. 0.4. What is the difference between the Exports(as % of merchandise exports) in Gabon in 1968 and the Exports(as % of merchandise exports) in Sudan in 1969?
Your answer should be compact. 26.43. What is the difference between the Exports(as % of merchandise exports) of Chad in 1968 and the Exports(as % of merchandise exports) of Egypt, Arab Rep. in 1970?
Give a very brief answer. -0.43. What is the difference between the Exports(as % of merchandise exports) in Chad in 1968 and the Exports(as % of merchandise exports) in Gabon in 1970?
Make the answer very short. -13.55. What is the difference between the Exports(as % of merchandise exports) in Chad in 1968 and the Exports(as % of merchandise exports) in Sudan in 1970?
Provide a succinct answer. -0.27. What is the difference between the Exports(as % of merchandise exports) of Egypt, Arab Rep. in 1968 and the Exports(as % of merchandise exports) of Gabon in 1970?
Provide a short and direct response. -12.83. What is the difference between the Exports(as % of merchandise exports) of Egypt, Arab Rep. in 1968 and the Exports(as % of merchandise exports) of Sudan in 1970?
Make the answer very short. 0.46. What is the difference between the Exports(as % of merchandise exports) of Gabon in 1968 and the Exports(as % of merchandise exports) of Sudan in 1970?
Provide a short and direct response. 26.48. What is the difference between the Exports(as % of merchandise exports) in Chad in 1968 and the Exports(as % of merchandise exports) in Egypt, Arab Rep. in 1971?
Provide a succinct answer. -0.32. What is the difference between the Exports(as % of merchandise exports) in Chad in 1968 and the Exports(as % of merchandise exports) in Gabon in 1971?
Offer a terse response. -21.93. What is the difference between the Exports(as % of merchandise exports) in Chad in 1968 and the Exports(as % of merchandise exports) in Sudan in 1971?
Offer a terse response. -0.24. What is the difference between the Exports(as % of merchandise exports) of Egypt, Arab Rep. in 1968 and the Exports(as % of merchandise exports) of Gabon in 1971?
Ensure brevity in your answer.  -21.21. What is the difference between the Exports(as % of merchandise exports) in Egypt, Arab Rep. in 1968 and the Exports(as % of merchandise exports) in Sudan in 1971?
Give a very brief answer. 0.48. What is the difference between the Exports(as % of merchandise exports) of Gabon in 1968 and the Exports(as % of merchandise exports) of Sudan in 1971?
Offer a very short reply. 26.51. What is the difference between the Exports(as % of merchandise exports) of Chad in 1968 and the Exports(as % of merchandise exports) of Egypt, Arab Rep. in 1975?
Ensure brevity in your answer.  -0.4. What is the difference between the Exports(as % of merchandise exports) in Chad in 1968 and the Exports(as % of merchandise exports) in Gabon in 1975?
Offer a terse response. -10.07. What is the difference between the Exports(as % of merchandise exports) in Chad in 1968 and the Exports(as % of merchandise exports) in Sudan in 1975?
Offer a very short reply. -0.47. What is the difference between the Exports(as % of merchandise exports) in Egypt, Arab Rep. in 1968 and the Exports(as % of merchandise exports) in Gabon in 1975?
Ensure brevity in your answer.  -9.35. What is the difference between the Exports(as % of merchandise exports) in Egypt, Arab Rep. in 1968 and the Exports(as % of merchandise exports) in Sudan in 1975?
Give a very brief answer. 0.25. What is the difference between the Exports(as % of merchandise exports) of Gabon in 1968 and the Exports(as % of merchandise exports) of Sudan in 1975?
Your answer should be very brief. 26.28. What is the difference between the Exports(as % of merchandise exports) of Chad in 1969 and the Exports(as % of merchandise exports) of Egypt, Arab Rep. in 1970?
Ensure brevity in your answer.  0.15. What is the difference between the Exports(as % of merchandise exports) of Chad in 1969 and the Exports(as % of merchandise exports) of Gabon in 1970?
Offer a very short reply. -12.97. What is the difference between the Exports(as % of merchandise exports) in Chad in 1969 and the Exports(as % of merchandise exports) in Sudan in 1970?
Keep it short and to the point. 0.31. What is the difference between the Exports(as % of merchandise exports) of Egypt, Arab Rep. in 1969 and the Exports(as % of merchandise exports) of Gabon in 1970?
Offer a very short reply. -13.07. What is the difference between the Exports(as % of merchandise exports) in Egypt, Arab Rep. in 1969 and the Exports(as % of merchandise exports) in Sudan in 1970?
Keep it short and to the point. 0.21. What is the difference between the Exports(as % of merchandise exports) in Gabon in 1969 and the Exports(as % of merchandise exports) in Sudan in 1970?
Offer a very short reply. 25.04. What is the difference between the Exports(as % of merchandise exports) of Chad in 1969 and the Exports(as % of merchandise exports) of Egypt, Arab Rep. in 1971?
Ensure brevity in your answer.  0.26. What is the difference between the Exports(as % of merchandise exports) of Chad in 1969 and the Exports(as % of merchandise exports) of Gabon in 1971?
Offer a very short reply. -21.35. What is the difference between the Exports(as % of merchandise exports) in Chad in 1969 and the Exports(as % of merchandise exports) in Sudan in 1971?
Your response must be concise. 0.34. What is the difference between the Exports(as % of merchandise exports) of Egypt, Arab Rep. in 1969 and the Exports(as % of merchandise exports) of Gabon in 1971?
Make the answer very short. -21.45. What is the difference between the Exports(as % of merchandise exports) in Egypt, Arab Rep. in 1969 and the Exports(as % of merchandise exports) in Sudan in 1971?
Offer a terse response. 0.24. What is the difference between the Exports(as % of merchandise exports) of Gabon in 1969 and the Exports(as % of merchandise exports) of Sudan in 1971?
Your response must be concise. 25.06. What is the difference between the Exports(as % of merchandise exports) of Chad in 1969 and the Exports(as % of merchandise exports) of Egypt, Arab Rep. in 1975?
Your response must be concise. 0.18. What is the difference between the Exports(as % of merchandise exports) in Chad in 1969 and the Exports(as % of merchandise exports) in Gabon in 1975?
Keep it short and to the point. -9.49. What is the difference between the Exports(as % of merchandise exports) of Chad in 1969 and the Exports(as % of merchandise exports) of Sudan in 1975?
Provide a succinct answer. 0.11. What is the difference between the Exports(as % of merchandise exports) of Egypt, Arab Rep. in 1969 and the Exports(as % of merchandise exports) of Gabon in 1975?
Keep it short and to the point. -9.59. What is the difference between the Exports(as % of merchandise exports) of Egypt, Arab Rep. in 1969 and the Exports(as % of merchandise exports) of Sudan in 1975?
Provide a short and direct response. 0.01. What is the difference between the Exports(as % of merchandise exports) in Gabon in 1969 and the Exports(as % of merchandise exports) in Sudan in 1975?
Your response must be concise. 24.83. What is the difference between the Exports(as % of merchandise exports) in Chad in 1970 and the Exports(as % of merchandise exports) in Egypt, Arab Rep. in 1971?
Your answer should be very brief. -0.22. What is the difference between the Exports(as % of merchandise exports) of Chad in 1970 and the Exports(as % of merchandise exports) of Gabon in 1971?
Make the answer very short. -21.83. What is the difference between the Exports(as % of merchandise exports) in Chad in 1970 and the Exports(as % of merchandise exports) in Sudan in 1971?
Provide a short and direct response. -0.15. What is the difference between the Exports(as % of merchandise exports) in Egypt, Arab Rep. in 1970 and the Exports(as % of merchandise exports) in Gabon in 1971?
Offer a terse response. -21.5. What is the difference between the Exports(as % of merchandise exports) in Egypt, Arab Rep. in 1970 and the Exports(as % of merchandise exports) in Sudan in 1971?
Your response must be concise. 0.19. What is the difference between the Exports(as % of merchandise exports) of Gabon in 1970 and the Exports(as % of merchandise exports) of Sudan in 1971?
Your answer should be very brief. 13.31. What is the difference between the Exports(as % of merchandise exports) of Chad in 1970 and the Exports(as % of merchandise exports) of Egypt, Arab Rep. in 1975?
Make the answer very short. -0.3. What is the difference between the Exports(as % of merchandise exports) in Chad in 1970 and the Exports(as % of merchandise exports) in Gabon in 1975?
Give a very brief answer. -9.97. What is the difference between the Exports(as % of merchandise exports) in Chad in 1970 and the Exports(as % of merchandise exports) in Sudan in 1975?
Your answer should be compact. -0.38. What is the difference between the Exports(as % of merchandise exports) in Egypt, Arab Rep. in 1970 and the Exports(as % of merchandise exports) in Gabon in 1975?
Provide a succinct answer. -9.64. What is the difference between the Exports(as % of merchandise exports) of Egypt, Arab Rep. in 1970 and the Exports(as % of merchandise exports) of Sudan in 1975?
Your answer should be very brief. -0.04. What is the difference between the Exports(as % of merchandise exports) of Gabon in 1970 and the Exports(as % of merchandise exports) of Sudan in 1975?
Provide a succinct answer. 13.08. What is the difference between the Exports(as % of merchandise exports) in Chad in 1971 and the Exports(as % of merchandise exports) in Egypt, Arab Rep. in 1975?
Make the answer very short. -0.36. What is the difference between the Exports(as % of merchandise exports) in Chad in 1971 and the Exports(as % of merchandise exports) in Gabon in 1975?
Your answer should be very brief. -10.03. What is the difference between the Exports(as % of merchandise exports) in Chad in 1971 and the Exports(as % of merchandise exports) in Sudan in 1975?
Your answer should be compact. -0.44. What is the difference between the Exports(as % of merchandise exports) in Egypt, Arab Rep. in 1971 and the Exports(as % of merchandise exports) in Gabon in 1975?
Keep it short and to the point. -9.76. What is the difference between the Exports(as % of merchandise exports) in Egypt, Arab Rep. in 1971 and the Exports(as % of merchandise exports) in Sudan in 1975?
Keep it short and to the point. -0.16. What is the difference between the Exports(as % of merchandise exports) in Gabon in 1971 and the Exports(as % of merchandise exports) in Sudan in 1975?
Ensure brevity in your answer.  21.46. What is the average Exports(as % of merchandise exports) in Chad per year?
Ensure brevity in your answer.  0.55. What is the average Exports(as % of merchandise exports) in Egypt, Arab Rep. per year?
Your answer should be very brief. 0.96. What is the average Exports(as % of merchandise exports) in Gabon per year?
Your response must be concise. 26.16. What is the average Exports(as % of merchandise exports) in Sudan per year?
Provide a succinct answer. 0.53. In the year 1965, what is the difference between the Exports(as % of merchandise exports) in Chad and Exports(as % of merchandise exports) in Egypt, Arab Rep.?
Your response must be concise. -0.08. In the year 1965, what is the difference between the Exports(as % of merchandise exports) in Chad and Exports(as % of merchandise exports) in Gabon?
Your answer should be compact. -35.97. In the year 1965, what is the difference between the Exports(as % of merchandise exports) in Chad and Exports(as % of merchandise exports) in Sudan?
Your response must be concise. 0.35. In the year 1965, what is the difference between the Exports(as % of merchandise exports) in Egypt, Arab Rep. and Exports(as % of merchandise exports) in Gabon?
Offer a terse response. -35.89. In the year 1965, what is the difference between the Exports(as % of merchandise exports) of Egypt, Arab Rep. and Exports(as % of merchandise exports) of Sudan?
Your answer should be very brief. 0.43. In the year 1965, what is the difference between the Exports(as % of merchandise exports) in Gabon and Exports(as % of merchandise exports) in Sudan?
Offer a terse response. 36.32. In the year 1966, what is the difference between the Exports(as % of merchandise exports) of Chad and Exports(as % of merchandise exports) of Egypt, Arab Rep.?
Provide a succinct answer. -0.42. In the year 1966, what is the difference between the Exports(as % of merchandise exports) in Chad and Exports(as % of merchandise exports) in Gabon?
Make the answer very short. -39.4. In the year 1966, what is the difference between the Exports(as % of merchandise exports) in Chad and Exports(as % of merchandise exports) in Sudan?
Your answer should be compact. -0.1. In the year 1966, what is the difference between the Exports(as % of merchandise exports) in Egypt, Arab Rep. and Exports(as % of merchandise exports) in Gabon?
Keep it short and to the point. -38.98. In the year 1966, what is the difference between the Exports(as % of merchandise exports) in Egypt, Arab Rep. and Exports(as % of merchandise exports) in Sudan?
Provide a short and direct response. 0.31. In the year 1966, what is the difference between the Exports(as % of merchandise exports) in Gabon and Exports(as % of merchandise exports) in Sudan?
Provide a succinct answer. 39.3. In the year 1967, what is the difference between the Exports(as % of merchandise exports) in Chad and Exports(as % of merchandise exports) in Egypt, Arab Rep.?
Provide a succinct answer. -1.88. In the year 1967, what is the difference between the Exports(as % of merchandise exports) of Chad and Exports(as % of merchandise exports) of Gabon?
Ensure brevity in your answer.  -33.3. In the year 1967, what is the difference between the Exports(as % of merchandise exports) in Chad and Exports(as % of merchandise exports) in Sudan?
Offer a very short reply. 0.08. In the year 1967, what is the difference between the Exports(as % of merchandise exports) of Egypt, Arab Rep. and Exports(as % of merchandise exports) of Gabon?
Your answer should be very brief. -31.42. In the year 1967, what is the difference between the Exports(as % of merchandise exports) of Egypt, Arab Rep. and Exports(as % of merchandise exports) of Sudan?
Offer a very short reply. 1.95. In the year 1967, what is the difference between the Exports(as % of merchandise exports) in Gabon and Exports(as % of merchandise exports) in Sudan?
Keep it short and to the point. 33.37. In the year 1968, what is the difference between the Exports(as % of merchandise exports) in Chad and Exports(as % of merchandise exports) in Egypt, Arab Rep.?
Make the answer very short. -0.73. In the year 1968, what is the difference between the Exports(as % of merchandise exports) in Chad and Exports(as % of merchandise exports) in Gabon?
Ensure brevity in your answer.  -26.75. In the year 1968, what is the difference between the Exports(as % of merchandise exports) in Chad and Exports(as % of merchandise exports) in Sudan?
Ensure brevity in your answer.  -0.32. In the year 1968, what is the difference between the Exports(as % of merchandise exports) in Egypt, Arab Rep. and Exports(as % of merchandise exports) in Gabon?
Provide a succinct answer. -26.02. In the year 1968, what is the difference between the Exports(as % of merchandise exports) of Egypt, Arab Rep. and Exports(as % of merchandise exports) of Sudan?
Your answer should be very brief. 0.41. In the year 1968, what is the difference between the Exports(as % of merchandise exports) in Gabon and Exports(as % of merchandise exports) in Sudan?
Give a very brief answer. 26.43. In the year 1969, what is the difference between the Exports(as % of merchandise exports) of Chad and Exports(as % of merchandise exports) of Egypt, Arab Rep.?
Ensure brevity in your answer.  0.1. In the year 1969, what is the difference between the Exports(as % of merchandise exports) of Chad and Exports(as % of merchandise exports) of Gabon?
Ensure brevity in your answer.  -24.72. In the year 1969, what is the difference between the Exports(as % of merchandise exports) in Chad and Exports(as % of merchandise exports) in Sudan?
Make the answer very short. 0.26. In the year 1969, what is the difference between the Exports(as % of merchandise exports) of Egypt, Arab Rep. and Exports(as % of merchandise exports) of Gabon?
Your response must be concise. -24.82. In the year 1969, what is the difference between the Exports(as % of merchandise exports) in Egypt, Arab Rep. and Exports(as % of merchandise exports) in Sudan?
Make the answer very short. 0.16. In the year 1969, what is the difference between the Exports(as % of merchandise exports) in Gabon and Exports(as % of merchandise exports) in Sudan?
Your answer should be compact. 24.98. In the year 1970, what is the difference between the Exports(as % of merchandise exports) in Chad and Exports(as % of merchandise exports) in Egypt, Arab Rep.?
Make the answer very short. -0.34. In the year 1970, what is the difference between the Exports(as % of merchandise exports) in Chad and Exports(as % of merchandise exports) in Gabon?
Ensure brevity in your answer.  -13.46. In the year 1970, what is the difference between the Exports(as % of merchandise exports) of Chad and Exports(as % of merchandise exports) of Sudan?
Make the answer very short. -0.17. In the year 1970, what is the difference between the Exports(as % of merchandise exports) of Egypt, Arab Rep. and Exports(as % of merchandise exports) of Gabon?
Your response must be concise. -13.12. In the year 1970, what is the difference between the Exports(as % of merchandise exports) in Egypt, Arab Rep. and Exports(as % of merchandise exports) in Sudan?
Offer a very short reply. 0.16. In the year 1970, what is the difference between the Exports(as % of merchandise exports) of Gabon and Exports(as % of merchandise exports) of Sudan?
Offer a terse response. 13.28. In the year 1971, what is the difference between the Exports(as % of merchandise exports) of Chad and Exports(as % of merchandise exports) of Egypt, Arab Rep.?
Ensure brevity in your answer.  -0.28. In the year 1971, what is the difference between the Exports(as % of merchandise exports) of Chad and Exports(as % of merchandise exports) of Gabon?
Offer a very short reply. -21.89. In the year 1971, what is the difference between the Exports(as % of merchandise exports) in Chad and Exports(as % of merchandise exports) in Sudan?
Offer a very short reply. -0.21. In the year 1971, what is the difference between the Exports(as % of merchandise exports) of Egypt, Arab Rep. and Exports(as % of merchandise exports) of Gabon?
Make the answer very short. -21.62. In the year 1971, what is the difference between the Exports(as % of merchandise exports) of Egypt, Arab Rep. and Exports(as % of merchandise exports) of Sudan?
Your answer should be very brief. 0.07. In the year 1971, what is the difference between the Exports(as % of merchandise exports) in Gabon and Exports(as % of merchandise exports) in Sudan?
Provide a succinct answer. 21.69. In the year 1975, what is the difference between the Exports(as % of merchandise exports) in Chad and Exports(as % of merchandise exports) in Egypt, Arab Rep.?
Ensure brevity in your answer.  0.3. In the year 1975, what is the difference between the Exports(as % of merchandise exports) in Chad and Exports(as % of merchandise exports) in Gabon?
Make the answer very short. -9.37. In the year 1975, what is the difference between the Exports(as % of merchandise exports) in Chad and Exports(as % of merchandise exports) in Sudan?
Make the answer very short. 0.23. In the year 1975, what is the difference between the Exports(as % of merchandise exports) in Egypt, Arab Rep. and Exports(as % of merchandise exports) in Gabon?
Provide a succinct answer. -9.67. In the year 1975, what is the difference between the Exports(as % of merchandise exports) in Egypt, Arab Rep. and Exports(as % of merchandise exports) in Sudan?
Your response must be concise. -0.07. In the year 1975, what is the difference between the Exports(as % of merchandise exports) in Gabon and Exports(as % of merchandise exports) in Sudan?
Your answer should be compact. 9.6. What is the ratio of the Exports(as % of merchandise exports) in Chad in 1965 to that in 1966?
Offer a terse response. 1.35. What is the ratio of the Exports(as % of merchandise exports) of Egypt, Arab Rep. in 1965 to that in 1966?
Offer a very short reply. 0.94. What is the ratio of the Exports(as % of merchandise exports) in Gabon in 1965 to that in 1966?
Provide a short and direct response. 0.92. What is the ratio of the Exports(as % of merchandise exports) of Sudan in 1965 to that in 1966?
Your answer should be very brief. 0.78. What is the ratio of the Exports(as % of merchandise exports) of Chad in 1965 to that in 1967?
Offer a terse response. 1.66. What is the ratio of the Exports(as % of merchandise exports) in Egypt, Arab Rep. in 1965 to that in 1967?
Offer a terse response. 0.44. What is the ratio of the Exports(as % of merchandise exports) of Gabon in 1965 to that in 1967?
Your response must be concise. 1.09. What is the ratio of the Exports(as % of merchandise exports) of Sudan in 1965 to that in 1967?
Provide a short and direct response. 1.24. What is the ratio of the Exports(as % of merchandise exports) of Chad in 1965 to that in 1968?
Keep it short and to the point. 8.26. What is the ratio of the Exports(as % of merchandise exports) in Egypt, Arab Rep. in 1965 to that in 1968?
Offer a terse response. 1.28. What is the ratio of the Exports(as % of merchandise exports) in Gabon in 1965 to that in 1968?
Keep it short and to the point. 1.38. What is the ratio of the Exports(as % of merchandise exports) of Sudan in 1965 to that in 1968?
Your response must be concise. 1.5. What is the ratio of the Exports(as % of merchandise exports) in Chad in 1965 to that in 1969?
Your answer should be very brief. 1.43. What is the ratio of the Exports(as % of merchandise exports) of Egypt, Arab Rep. in 1965 to that in 1969?
Offer a terse response. 1.79. What is the ratio of the Exports(as % of merchandise exports) of Gabon in 1965 to that in 1969?
Keep it short and to the point. 1.45. What is the ratio of the Exports(as % of merchandise exports) in Sudan in 1965 to that in 1969?
Provide a short and direct response. 1.48. What is the ratio of the Exports(as % of merchandise exports) in Chad in 1965 to that in 1970?
Ensure brevity in your answer.  4.59. What is the ratio of the Exports(as % of merchandise exports) of Egypt, Arab Rep. in 1965 to that in 1970?
Provide a succinct answer. 1.96. What is the ratio of the Exports(as % of merchandise exports) of Gabon in 1965 to that in 1970?
Your response must be concise. 2.7. What is the ratio of the Exports(as % of merchandise exports) of Sudan in 1965 to that in 1970?
Provide a short and direct response. 1.68. What is the ratio of the Exports(as % of merchandise exports) in Chad in 1965 to that in 1971?
Your answer should be very brief. 6.31. What is the ratio of the Exports(as % of merchandise exports) of Egypt, Arab Rep. in 1965 to that in 1971?
Keep it short and to the point. 2.48. What is the ratio of the Exports(as % of merchandise exports) of Gabon in 1965 to that in 1971?
Keep it short and to the point. 1.68. What is the ratio of the Exports(as % of merchandise exports) of Sudan in 1965 to that in 1971?
Offer a terse response. 1.81. What is the ratio of the Exports(as % of merchandise exports) in Chad in 1965 to that in 1975?
Offer a terse response. 1.22. What is the ratio of the Exports(as % of merchandise exports) in Egypt, Arab Rep. in 1965 to that in 1975?
Give a very brief answer. 2.08. What is the ratio of the Exports(as % of merchandise exports) in Gabon in 1965 to that in 1975?
Provide a succinct answer. 3.63. What is the ratio of the Exports(as % of merchandise exports) of Sudan in 1965 to that in 1975?
Your answer should be very brief. 1.11. What is the ratio of the Exports(as % of merchandise exports) of Chad in 1966 to that in 1967?
Keep it short and to the point. 1.23. What is the ratio of the Exports(as % of merchandise exports) of Egypt, Arab Rep. in 1966 to that in 1967?
Ensure brevity in your answer.  0.47. What is the ratio of the Exports(as % of merchandise exports) in Gabon in 1966 to that in 1967?
Give a very brief answer. 1.18. What is the ratio of the Exports(as % of merchandise exports) in Sudan in 1966 to that in 1967?
Provide a succinct answer. 1.6. What is the ratio of the Exports(as % of merchandise exports) in Chad in 1966 to that in 1968?
Offer a terse response. 6.12. What is the ratio of the Exports(as % of merchandise exports) of Egypt, Arab Rep. in 1966 to that in 1968?
Keep it short and to the point. 1.37. What is the ratio of the Exports(as % of merchandise exports) in Gabon in 1966 to that in 1968?
Your answer should be very brief. 1.49. What is the ratio of the Exports(as % of merchandise exports) in Sudan in 1966 to that in 1968?
Provide a succinct answer. 1.92. What is the ratio of the Exports(as % of merchandise exports) in Chad in 1966 to that in 1969?
Make the answer very short. 1.06. What is the ratio of the Exports(as % of merchandise exports) in Egypt, Arab Rep. in 1966 to that in 1969?
Give a very brief answer. 1.92. What is the ratio of the Exports(as % of merchandise exports) of Gabon in 1966 to that in 1969?
Make the answer very short. 1.58. What is the ratio of the Exports(as % of merchandise exports) of Sudan in 1966 to that in 1969?
Offer a terse response. 1.9. What is the ratio of the Exports(as % of merchandise exports) in Chad in 1966 to that in 1970?
Offer a very short reply. 3.4. What is the ratio of the Exports(as % of merchandise exports) of Egypt, Arab Rep. in 1966 to that in 1970?
Offer a terse response. 2.09. What is the ratio of the Exports(as % of merchandise exports) in Gabon in 1966 to that in 1970?
Offer a terse response. 2.94. What is the ratio of the Exports(as % of merchandise exports) of Sudan in 1966 to that in 1970?
Give a very brief answer. 2.16. What is the ratio of the Exports(as % of merchandise exports) in Chad in 1966 to that in 1971?
Your answer should be very brief. 4.68. What is the ratio of the Exports(as % of merchandise exports) of Egypt, Arab Rep. in 1966 to that in 1971?
Your response must be concise. 2.65. What is the ratio of the Exports(as % of merchandise exports) in Gabon in 1966 to that in 1971?
Keep it short and to the point. 1.82. What is the ratio of the Exports(as % of merchandise exports) in Sudan in 1966 to that in 1971?
Keep it short and to the point. 2.32. What is the ratio of the Exports(as % of merchandise exports) of Chad in 1966 to that in 1975?
Provide a succinct answer. 0.91. What is the ratio of the Exports(as % of merchandise exports) in Egypt, Arab Rep. in 1966 to that in 1975?
Offer a very short reply. 2.22. What is the ratio of the Exports(as % of merchandise exports) of Gabon in 1966 to that in 1975?
Offer a terse response. 3.94. What is the ratio of the Exports(as % of merchandise exports) in Sudan in 1966 to that in 1975?
Your answer should be very brief. 1.42. What is the ratio of the Exports(as % of merchandise exports) of Chad in 1967 to that in 1968?
Keep it short and to the point. 4.98. What is the ratio of the Exports(as % of merchandise exports) of Egypt, Arab Rep. in 1967 to that in 1968?
Keep it short and to the point. 2.92. What is the ratio of the Exports(as % of merchandise exports) of Gabon in 1967 to that in 1968?
Offer a very short reply. 1.26. What is the ratio of the Exports(as % of merchandise exports) in Sudan in 1967 to that in 1968?
Your answer should be compact. 1.21. What is the ratio of the Exports(as % of merchandise exports) of Chad in 1967 to that in 1969?
Keep it short and to the point. 0.86. What is the ratio of the Exports(as % of merchandise exports) in Egypt, Arab Rep. in 1967 to that in 1969?
Keep it short and to the point. 4.1. What is the ratio of the Exports(as % of merchandise exports) in Sudan in 1967 to that in 1969?
Offer a terse response. 1.19. What is the ratio of the Exports(as % of merchandise exports) in Chad in 1967 to that in 1970?
Your answer should be very brief. 2.77. What is the ratio of the Exports(as % of merchandise exports) in Egypt, Arab Rep. in 1967 to that in 1970?
Provide a succinct answer. 4.48. What is the ratio of the Exports(as % of merchandise exports) in Gabon in 1967 to that in 1970?
Give a very brief answer. 2.48. What is the ratio of the Exports(as % of merchandise exports) of Sudan in 1967 to that in 1970?
Ensure brevity in your answer.  1.35. What is the ratio of the Exports(as % of merchandise exports) in Chad in 1967 to that in 1971?
Offer a terse response. 3.8. What is the ratio of the Exports(as % of merchandise exports) of Egypt, Arab Rep. in 1967 to that in 1971?
Make the answer very short. 5.66. What is the ratio of the Exports(as % of merchandise exports) of Gabon in 1967 to that in 1971?
Provide a succinct answer. 1.54. What is the ratio of the Exports(as % of merchandise exports) of Sudan in 1967 to that in 1971?
Offer a terse response. 1.45. What is the ratio of the Exports(as % of merchandise exports) of Chad in 1967 to that in 1975?
Ensure brevity in your answer.  0.74. What is the ratio of the Exports(as % of merchandise exports) in Egypt, Arab Rep. in 1967 to that in 1975?
Offer a very short reply. 4.74. What is the ratio of the Exports(as % of merchandise exports) in Gabon in 1967 to that in 1975?
Your response must be concise. 3.33. What is the ratio of the Exports(as % of merchandise exports) of Sudan in 1967 to that in 1975?
Your answer should be compact. 0.89. What is the ratio of the Exports(as % of merchandise exports) in Chad in 1968 to that in 1969?
Keep it short and to the point. 0.17. What is the ratio of the Exports(as % of merchandise exports) of Egypt, Arab Rep. in 1968 to that in 1969?
Give a very brief answer. 1.4. What is the ratio of the Exports(as % of merchandise exports) in Gabon in 1968 to that in 1969?
Your answer should be very brief. 1.06. What is the ratio of the Exports(as % of merchandise exports) in Chad in 1968 to that in 1970?
Give a very brief answer. 0.56. What is the ratio of the Exports(as % of merchandise exports) of Egypt, Arab Rep. in 1968 to that in 1970?
Offer a very short reply. 1.53. What is the ratio of the Exports(as % of merchandise exports) in Gabon in 1968 to that in 1970?
Give a very brief answer. 1.96. What is the ratio of the Exports(as % of merchandise exports) in Sudan in 1968 to that in 1970?
Your response must be concise. 1.12. What is the ratio of the Exports(as % of merchandise exports) in Chad in 1968 to that in 1971?
Ensure brevity in your answer.  0.76. What is the ratio of the Exports(as % of merchandise exports) of Egypt, Arab Rep. in 1968 to that in 1971?
Your response must be concise. 1.93. What is the ratio of the Exports(as % of merchandise exports) in Gabon in 1968 to that in 1971?
Keep it short and to the point. 1.22. What is the ratio of the Exports(as % of merchandise exports) in Sudan in 1968 to that in 1971?
Ensure brevity in your answer.  1.2. What is the ratio of the Exports(as % of merchandise exports) of Chad in 1968 to that in 1975?
Provide a succinct answer. 0.15. What is the ratio of the Exports(as % of merchandise exports) in Egypt, Arab Rep. in 1968 to that in 1975?
Provide a short and direct response. 1.62. What is the ratio of the Exports(as % of merchandise exports) of Gabon in 1968 to that in 1975?
Provide a succinct answer. 2.64. What is the ratio of the Exports(as % of merchandise exports) of Sudan in 1968 to that in 1975?
Offer a terse response. 0.74. What is the ratio of the Exports(as % of merchandise exports) of Chad in 1969 to that in 1970?
Offer a terse response. 3.21. What is the ratio of the Exports(as % of merchandise exports) of Egypt, Arab Rep. in 1969 to that in 1970?
Keep it short and to the point. 1.09. What is the ratio of the Exports(as % of merchandise exports) in Gabon in 1969 to that in 1970?
Offer a terse response. 1.86. What is the ratio of the Exports(as % of merchandise exports) in Sudan in 1969 to that in 1970?
Offer a terse response. 1.14. What is the ratio of the Exports(as % of merchandise exports) of Chad in 1969 to that in 1971?
Give a very brief answer. 4.41. What is the ratio of the Exports(as % of merchandise exports) of Egypt, Arab Rep. in 1969 to that in 1971?
Offer a very short reply. 1.38. What is the ratio of the Exports(as % of merchandise exports) of Gabon in 1969 to that in 1971?
Your answer should be very brief. 1.15. What is the ratio of the Exports(as % of merchandise exports) of Sudan in 1969 to that in 1971?
Keep it short and to the point. 1.22. What is the ratio of the Exports(as % of merchandise exports) in Chad in 1969 to that in 1975?
Keep it short and to the point. 0.85. What is the ratio of the Exports(as % of merchandise exports) of Egypt, Arab Rep. in 1969 to that in 1975?
Provide a short and direct response. 1.16. What is the ratio of the Exports(as % of merchandise exports) in Gabon in 1969 to that in 1975?
Provide a short and direct response. 2.49. What is the ratio of the Exports(as % of merchandise exports) in Sudan in 1969 to that in 1975?
Keep it short and to the point. 0.75. What is the ratio of the Exports(as % of merchandise exports) of Chad in 1970 to that in 1971?
Provide a short and direct response. 1.37. What is the ratio of the Exports(as % of merchandise exports) in Egypt, Arab Rep. in 1970 to that in 1971?
Your response must be concise. 1.26. What is the ratio of the Exports(as % of merchandise exports) of Gabon in 1970 to that in 1971?
Provide a succinct answer. 0.62. What is the ratio of the Exports(as % of merchandise exports) in Sudan in 1970 to that in 1971?
Your response must be concise. 1.07. What is the ratio of the Exports(as % of merchandise exports) in Chad in 1970 to that in 1975?
Make the answer very short. 0.27. What is the ratio of the Exports(as % of merchandise exports) of Egypt, Arab Rep. in 1970 to that in 1975?
Give a very brief answer. 1.06. What is the ratio of the Exports(as % of merchandise exports) of Gabon in 1970 to that in 1975?
Give a very brief answer. 1.34. What is the ratio of the Exports(as % of merchandise exports) in Sudan in 1970 to that in 1975?
Provide a short and direct response. 0.66. What is the ratio of the Exports(as % of merchandise exports) of Chad in 1971 to that in 1975?
Your answer should be very brief. 0.19. What is the ratio of the Exports(as % of merchandise exports) in Egypt, Arab Rep. in 1971 to that in 1975?
Keep it short and to the point. 0.84. What is the ratio of the Exports(as % of merchandise exports) of Gabon in 1971 to that in 1975?
Give a very brief answer. 2.16. What is the ratio of the Exports(as % of merchandise exports) in Sudan in 1971 to that in 1975?
Make the answer very short. 0.61. What is the difference between the highest and the second highest Exports(as % of merchandise exports) in Chad?
Ensure brevity in your answer.  0.18. What is the difference between the highest and the second highest Exports(as % of merchandise exports) of Egypt, Arab Rep.?
Your answer should be compact. 1.32. What is the difference between the highest and the second highest Exports(as % of merchandise exports) in Gabon?
Keep it short and to the point. 3.17. What is the difference between the highest and the second highest Exports(as % of merchandise exports) of Sudan?
Provide a succinct answer. 0.19. What is the difference between the highest and the lowest Exports(as % of merchandise exports) of Chad?
Make the answer very short. 0.88. What is the difference between the highest and the lowest Exports(as % of merchandise exports) of Egypt, Arab Rep.?
Keep it short and to the point. 2.04. What is the difference between the highest and the lowest Exports(as % of merchandise exports) of Gabon?
Give a very brief answer. 29.95. What is the difference between the highest and the lowest Exports(as % of merchandise exports) in Sudan?
Your answer should be compact. 0.48. 